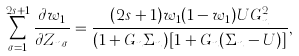<formula> <loc_0><loc_0><loc_500><loc_500>\sum _ { \sigma = 1 } ^ { 2 s + 1 } \frac { \partial w _ { 1 } } { \partial Z _ { n \sigma } } = \frac { ( 2 s + 1 ) w _ { 1 } ( 1 - w _ { 1 } ) U G _ { n } ^ { 2 } } { ( 1 + G _ { n } \Sigma _ { n } ) [ 1 + G _ { n } ( \Sigma _ { n } - U ) ] } ,</formula> 